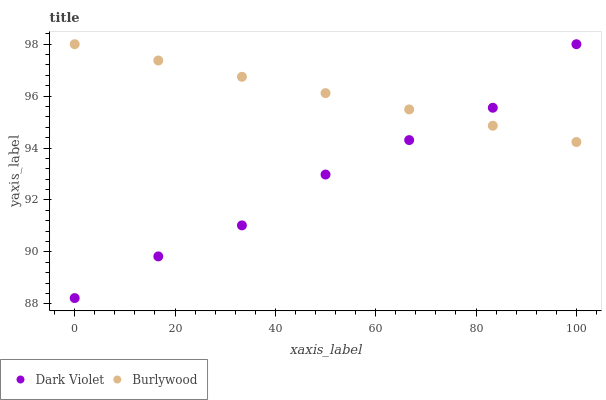Does Dark Violet have the minimum area under the curve?
Answer yes or no. Yes. Does Burlywood have the maximum area under the curve?
Answer yes or no. Yes. Does Dark Violet have the maximum area under the curve?
Answer yes or no. No. Is Burlywood the smoothest?
Answer yes or no. Yes. Is Dark Violet the roughest?
Answer yes or no. Yes. Is Dark Violet the smoothest?
Answer yes or no. No. Does Dark Violet have the lowest value?
Answer yes or no. Yes. Does Dark Violet have the highest value?
Answer yes or no. Yes. Does Burlywood intersect Dark Violet?
Answer yes or no. Yes. Is Burlywood less than Dark Violet?
Answer yes or no. No. Is Burlywood greater than Dark Violet?
Answer yes or no. No. 